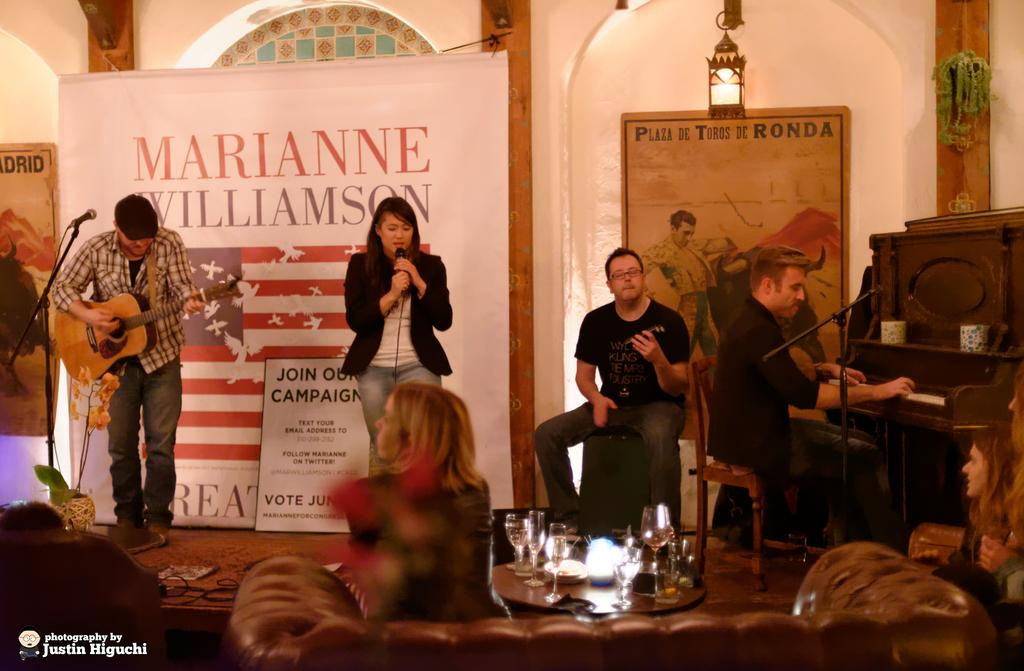How many people are in the image? There are people in the image. What are some of the people doing in the image? Some people are standing in the image. Can you describe the man in the image? The man in the image is playing a piano. What subject is the man teaching to his friend in the image? There is no indication in the image that the man is teaching a subject or has a friend present. 